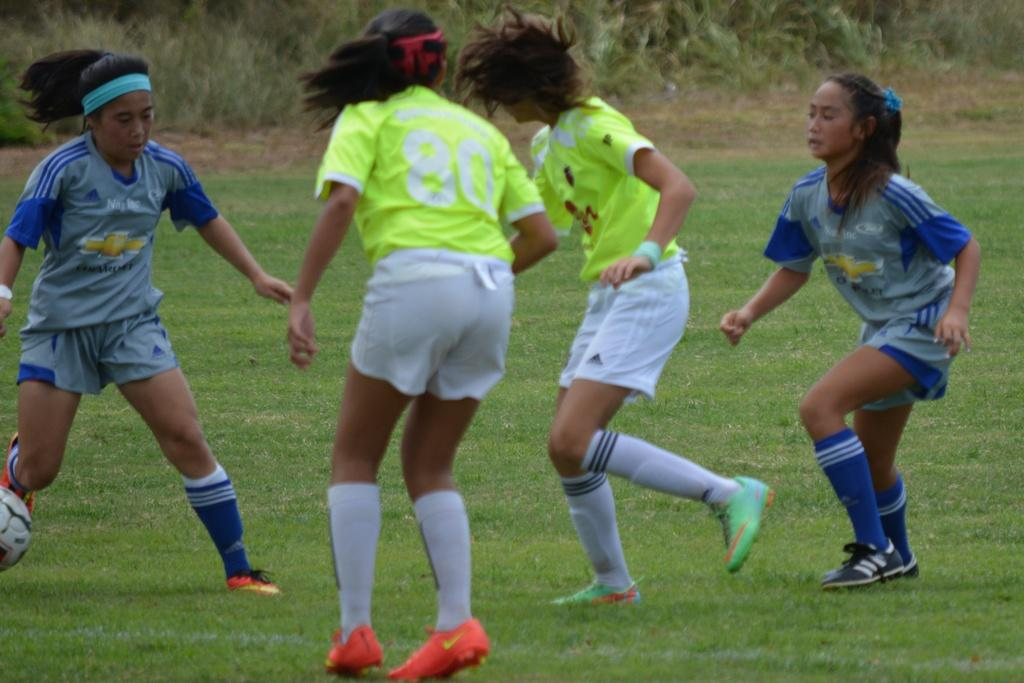How many people are in the image? There are four people in the image. What are the people doing in the image? The people are on the ground. What are the people wearing? The people are wearing different color jerseys. What object is to the left of the people? There is a ball to the left of the people. What can be seen in the background of the image? There are many trees in the background of the image. What type of throat-soothing remedy is being used by the people in the image? There is no throat-soothing remedy present in the image; the people are wearing jerseys and are likely engaged in a sport or game. 